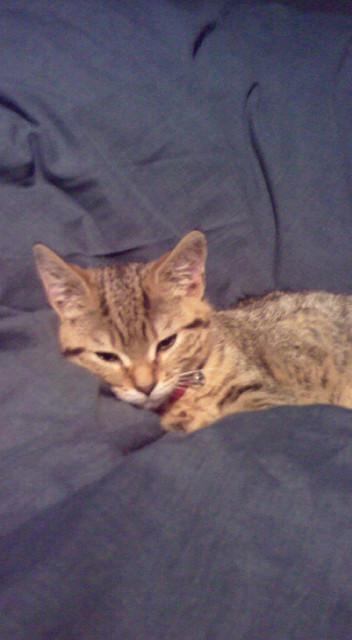What is the cat doing?
Quick response, please. Resting. What is the main color of the calico cat?
Be succinct. Brown. Is the can yawning?
Keep it brief. No. What type of cat is pictured?
Short answer required. Tiger. Is the cat trying to sleep?
Quick response, please. Yes. 